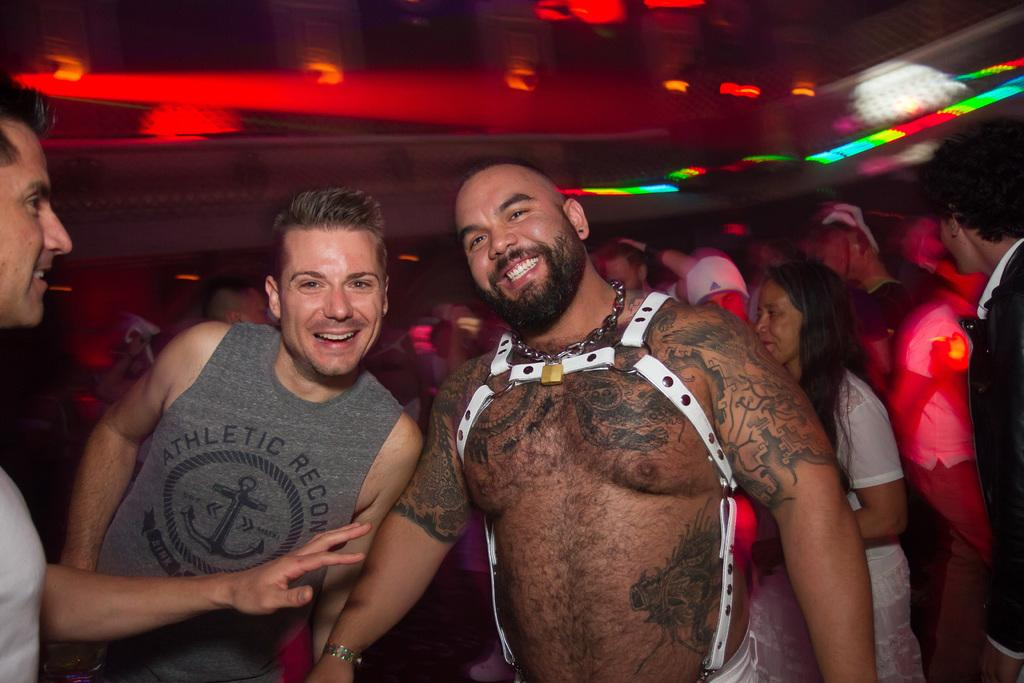How many people are present in the image? There are three people standing in the image. What is the facial expression of the people in the image? The people are smiling. What can be seen in the background of the image? There is a crowd in the background of the image. What is visible at the top of the image? There are lights visible at the top of the image. Are there any women in the image? The provided facts do not specify the gender of the people in the image, so we cannot definitively answer whether there are any women present. What rule is being enforced by the people in the image? There is no indication in the image of any rule being enforced or followed. Can you see any cobwebs in the image? There is no mention of cobwebs in the provided facts, and therefore we cannot determine if any are present in the image. 